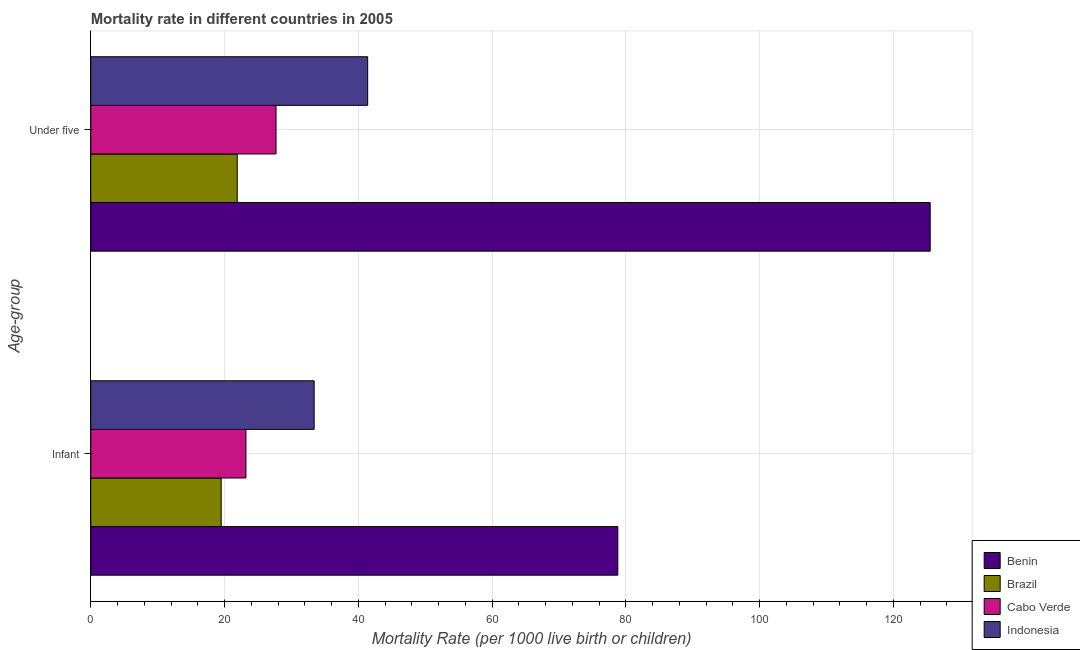How many different coloured bars are there?
Offer a very short reply. 4. Are the number of bars per tick equal to the number of legend labels?
Offer a terse response. Yes. How many bars are there on the 1st tick from the top?
Keep it short and to the point. 4. What is the label of the 2nd group of bars from the top?
Your answer should be compact. Infant. What is the infant mortality rate in Cabo Verde?
Your answer should be compact. 23.2. Across all countries, what is the maximum under-5 mortality rate?
Your answer should be very brief. 125.5. Across all countries, what is the minimum infant mortality rate?
Make the answer very short. 19.5. In which country was the infant mortality rate maximum?
Give a very brief answer. Benin. In which country was the infant mortality rate minimum?
Your answer should be compact. Brazil. What is the total infant mortality rate in the graph?
Provide a short and direct response. 154.9. What is the difference between the under-5 mortality rate in Benin and that in Indonesia?
Your answer should be very brief. 84.1. What is the difference between the under-5 mortality rate in Benin and the infant mortality rate in Cabo Verde?
Your response must be concise. 102.3. What is the average under-5 mortality rate per country?
Provide a succinct answer. 54.12. What is the ratio of the infant mortality rate in Cabo Verde to that in Benin?
Make the answer very short. 0.29. Is the infant mortality rate in Indonesia less than that in Brazil?
Offer a very short reply. No. In how many countries, is the under-5 mortality rate greater than the average under-5 mortality rate taken over all countries?
Ensure brevity in your answer.  1. What does the 2nd bar from the top in Under five represents?
Keep it short and to the point. Cabo Verde. What does the 2nd bar from the bottom in Infant represents?
Keep it short and to the point. Brazil. What is the difference between two consecutive major ticks on the X-axis?
Your answer should be compact. 20. Does the graph contain any zero values?
Keep it short and to the point. No. Does the graph contain grids?
Offer a terse response. Yes. How many legend labels are there?
Provide a short and direct response. 4. How are the legend labels stacked?
Your answer should be compact. Vertical. What is the title of the graph?
Give a very brief answer. Mortality rate in different countries in 2005. What is the label or title of the X-axis?
Provide a short and direct response. Mortality Rate (per 1000 live birth or children). What is the label or title of the Y-axis?
Provide a short and direct response. Age-group. What is the Mortality Rate (per 1000 live birth or children) of Benin in Infant?
Make the answer very short. 78.8. What is the Mortality Rate (per 1000 live birth or children) of Cabo Verde in Infant?
Your response must be concise. 23.2. What is the Mortality Rate (per 1000 live birth or children) of Indonesia in Infant?
Make the answer very short. 33.4. What is the Mortality Rate (per 1000 live birth or children) in Benin in Under five?
Offer a very short reply. 125.5. What is the Mortality Rate (per 1000 live birth or children) in Brazil in Under five?
Give a very brief answer. 21.9. What is the Mortality Rate (per 1000 live birth or children) of Cabo Verde in Under five?
Provide a short and direct response. 27.7. What is the Mortality Rate (per 1000 live birth or children) in Indonesia in Under five?
Offer a terse response. 41.4. Across all Age-group, what is the maximum Mortality Rate (per 1000 live birth or children) of Benin?
Your answer should be compact. 125.5. Across all Age-group, what is the maximum Mortality Rate (per 1000 live birth or children) in Brazil?
Your answer should be very brief. 21.9. Across all Age-group, what is the maximum Mortality Rate (per 1000 live birth or children) in Cabo Verde?
Ensure brevity in your answer.  27.7. Across all Age-group, what is the maximum Mortality Rate (per 1000 live birth or children) of Indonesia?
Your response must be concise. 41.4. Across all Age-group, what is the minimum Mortality Rate (per 1000 live birth or children) of Benin?
Make the answer very short. 78.8. Across all Age-group, what is the minimum Mortality Rate (per 1000 live birth or children) in Brazil?
Make the answer very short. 19.5. Across all Age-group, what is the minimum Mortality Rate (per 1000 live birth or children) in Cabo Verde?
Make the answer very short. 23.2. Across all Age-group, what is the minimum Mortality Rate (per 1000 live birth or children) in Indonesia?
Your answer should be compact. 33.4. What is the total Mortality Rate (per 1000 live birth or children) in Benin in the graph?
Your answer should be compact. 204.3. What is the total Mortality Rate (per 1000 live birth or children) of Brazil in the graph?
Make the answer very short. 41.4. What is the total Mortality Rate (per 1000 live birth or children) in Cabo Verde in the graph?
Keep it short and to the point. 50.9. What is the total Mortality Rate (per 1000 live birth or children) of Indonesia in the graph?
Provide a short and direct response. 74.8. What is the difference between the Mortality Rate (per 1000 live birth or children) in Benin in Infant and that in Under five?
Provide a short and direct response. -46.7. What is the difference between the Mortality Rate (per 1000 live birth or children) of Brazil in Infant and that in Under five?
Your answer should be very brief. -2.4. What is the difference between the Mortality Rate (per 1000 live birth or children) of Indonesia in Infant and that in Under five?
Your answer should be very brief. -8. What is the difference between the Mortality Rate (per 1000 live birth or children) in Benin in Infant and the Mortality Rate (per 1000 live birth or children) in Brazil in Under five?
Keep it short and to the point. 56.9. What is the difference between the Mortality Rate (per 1000 live birth or children) in Benin in Infant and the Mortality Rate (per 1000 live birth or children) in Cabo Verde in Under five?
Make the answer very short. 51.1. What is the difference between the Mortality Rate (per 1000 live birth or children) of Benin in Infant and the Mortality Rate (per 1000 live birth or children) of Indonesia in Under five?
Provide a short and direct response. 37.4. What is the difference between the Mortality Rate (per 1000 live birth or children) of Brazil in Infant and the Mortality Rate (per 1000 live birth or children) of Indonesia in Under five?
Offer a terse response. -21.9. What is the difference between the Mortality Rate (per 1000 live birth or children) of Cabo Verde in Infant and the Mortality Rate (per 1000 live birth or children) of Indonesia in Under five?
Keep it short and to the point. -18.2. What is the average Mortality Rate (per 1000 live birth or children) in Benin per Age-group?
Provide a succinct answer. 102.15. What is the average Mortality Rate (per 1000 live birth or children) of Brazil per Age-group?
Ensure brevity in your answer.  20.7. What is the average Mortality Rate (per 1000 live birth or children) of Cabo Verde per Age-group?
Offer a terse response. 25.45. What is the average Mortality Rate (per 1000 live birth or children) of Indonesia per Age-group?
Keep it short and to the point. 37.4. What is the difference between the Mortality Rate (per 1000 live birth or children) in Benin and Mortality Rate (per 1000 live birth or children) in Brazil in Infant?
Your answer should be compact. 59.3. What is the difference between the Mortality Rate (per 1000 live birth or children) of Benin and Mortality Rate (per 1000 live birth or children) of Cabo Verde in Infant?
Offer a terse response. 55.6. What is the difference between the Mortality Rate (per 1000 live birth or children) in Benin and Mortality Rate (per 1000 live birth or children) in Indonesia in Infant?
Provide a short and direct response. 45.4. What is the difference between the Mortality Rate (per 1000 live birth or children) of Brazil and Mortality Rate (per 1000 live birth or children) of Indonesia in Infant?
Your answer should be compact. -13.9. What is the difference between the Mortality Rate (per 1000 live birth or children) in Cabo Verde and Mortality Rate (per 1000 live birth or children) in Indonesia in Infant?
Provide a short and direct response. -10.2. What is the difference between the Mortality Rate (per 1000 live birth or children) of Benin and Mortality Rate (per 1000 live birth or children) of Brazil in Under five?
Give a very brief answer. 103.6. What is the difference between the Mortality Rate (per 1000 live birth or children) of Benin and Mortality Rate (per 1000 live birth or children) of Cabo Verde in Under five?
Give a very brief answer. 97.8. What is the difference between the Mortality Rate (per 1000 live birth or children) of Benin and Mortality Rate (per 1000 live birth or children) of Indonesia in Under five?
Keep it short and to the point. 84.1. What is the difference between the Mortality Rate (per 1000 live birth or children) in Brazil and Mortality Rate (per 1000 live birth or children) in Cabo Verde in Under five?
Offer a terse response. -5.8. What is the difference between the Mortality Rate (per 1000 live birth or children) of Brazil and Mortality Rate (per 1000 live birth or children) of Indonesia in Under five?
Keep it short and to the point. -19.5. What is the difference between the Mortality Rate (per 1000 live birth or children) of Cabo Verde and Mortality Rate (per 1000 live birth or children) of Indonesia in Under five?
Give a very brief answer. -13.7. What is the ratio of the Mortality Rate (per 1000 live birth or children) of Benin in Infant to that in Under five?
Your answer should be very brief. 0.63. What is the ratio of the Mortality Rate (per 1000 live birth or children) in Brazil in Infant to that in Under five?
Give a very brief answer. 0.89. What is the ratio of the Mortality Rate (per 1000 live birth or children) in Cabo Verde in Infant to that in Under five?
Ensure brevity in your answer.  0.84. What is the ratio of the Mortality Rate (per 1000 live birth or children) in Indonesia in Infant to that in Under five?
Give a very brief answer. 0.81. What is the difference between the highest and the second highest Mortality Rate (per 1000 live birth or children) of Benin?
Your response must be concise. 46.7. What is the difference between the highest and the second highest Mortality Rate (per 1000 live birth or children) in Brazil?
Give a very brief answer. 2.4. What is the difference between the highest and the lowest Mortality Rate (per 1000 live birth or children) of Benin?
Keep it short and to the point. 46.7. What is the difference between the highest and the lowest Mortality Rate (per 1000 live birth or children) in Cabo Verde?
Keep it short and to the point. 4.5. What is the difference between the highest and the lowest Mortality Rate (per 1000 live birth or children) in Indonesia?
Provide a succinct answer. 8. 